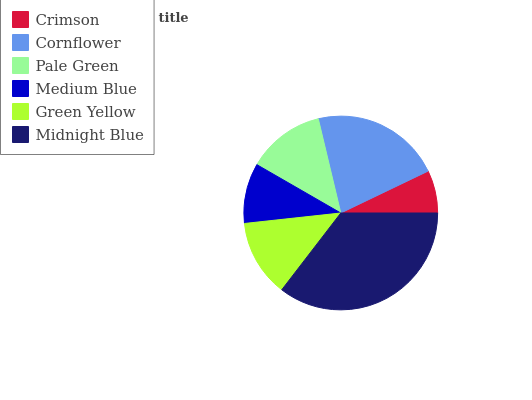Is Crimson the minimum?
Answer yes or no. Yes. Is Midnight Blue the maximum?
Answer yes or no. Yes. Is Cornflower the minimum?
Answer yes or no. No. Is Cornflower the maximum?
Answer yes or no. No. Is Cornflower greater than Crimson?
Answer yes or no. Yes. Is Crimson less than Cornflower?
Answer yes or no. Yes. Is Crimson greater than Cornflower?
Answer yes or no. No. Is Cornflower less than Crimson?
Answer yes or no. No. Is Pale Green the high median?
Answer yes or no. Yes. Is Green Yellow the low median?
Answer yes or no. Yes. Is Cornflower the high median?
Answer yes or no. No. Is Cornflower the low median?
Answer yes or no. No. 